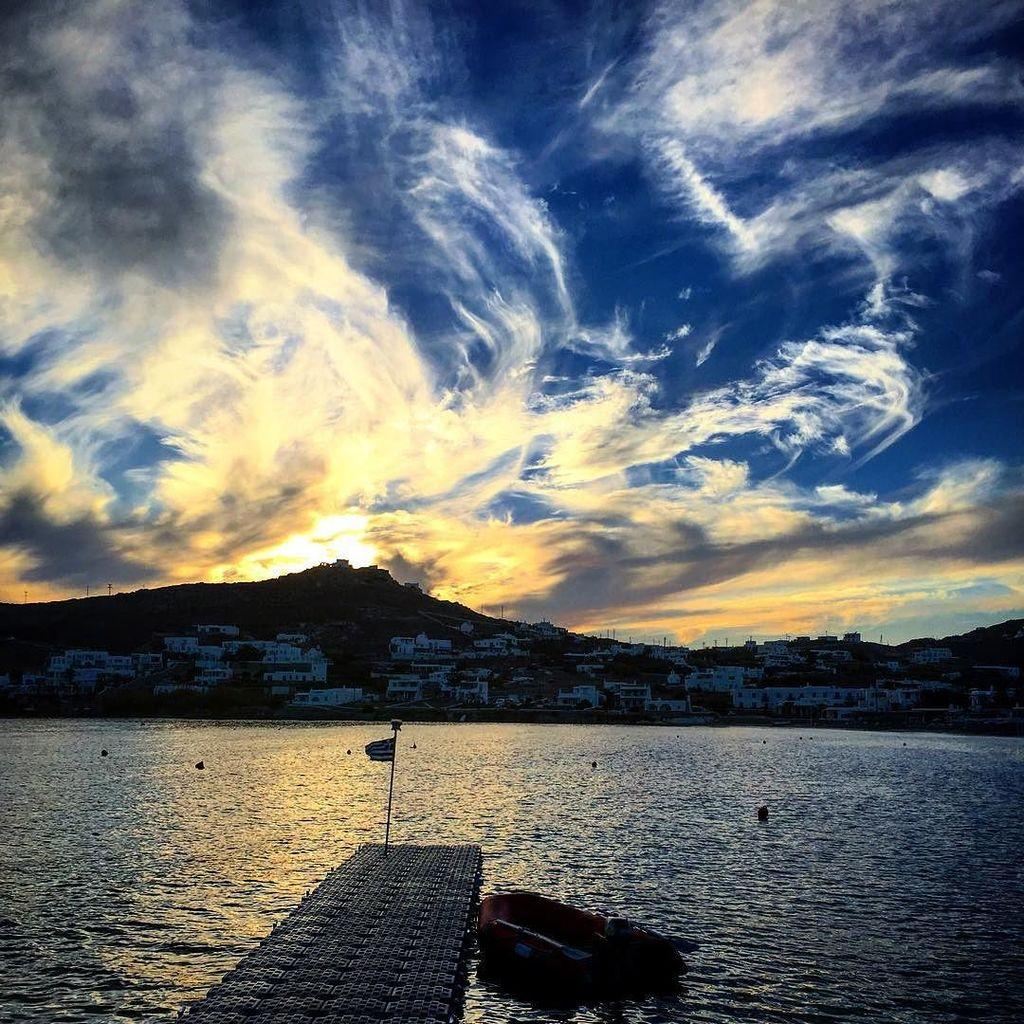What is on the surface of the sea in the image? There are boats on the surface of the sea in the image. What can be seen in the distance behind the boats? Houses are visible in the background of the image. What is on the mountain in the background of the image? Poles are present on the mountain in the background of the image. What is visible at the top of the image? The sky is visible at the top of the image. What can be seen in the sky? Clouds are present in the sky. Where is the stick used for cleaning teeth in the image? There is no stick used for cleaning teeth present in the image. What type of ornament is hanging from the boats in the image? There are no ornaments hanging from the boats in the image; only boats and the sea are visible. 